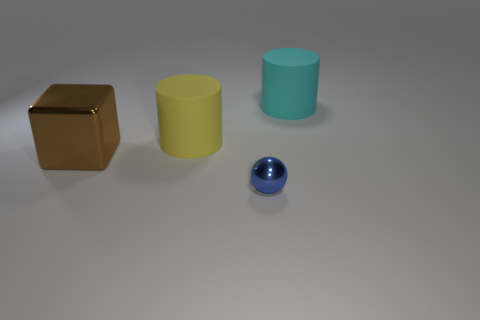Is the number of large brown metallic cubes that are in front of the big brown cube the same as the number of small blue metal balls that are right of the big cyan matte object?
Your answer should be very brief. Yes. What is the material of the big cylinder that is on the left side of the cylinder that is on the right side of the big yellow thing?
Give a very brief answer. Rubber. What number of things are either big purple metallic objects or large objects to the right of the brown metallic cube?
Your answer should be compact. 2. There is a ball that is the same material as the brown block; what is its size?
Offer a very short reply. Small. Are there more matte cylinders that are right of the cyan rubber cylinder than tiny shiny objects?
Make the answer very short. No. There is a object that is both left of the small object and behind the cube; how big is it?
Offer a very short reply. Large. There is a cyan thing that is the same shape as the yellow rubber thing; what is its material?
Provide a short and direct response. Rubber. Do the metallic thing that is in front of the brown block and the large brown thing have the same size?
Provide a succinct answer. No. There is a object that is both right of the yellow rubber object and behind the large brown thing; what is its color?
Provide a succinct answer. Cyan. How many tiny blue things are to the left of the thing in front of the brown block?
Provide a short and direct response. 0. 